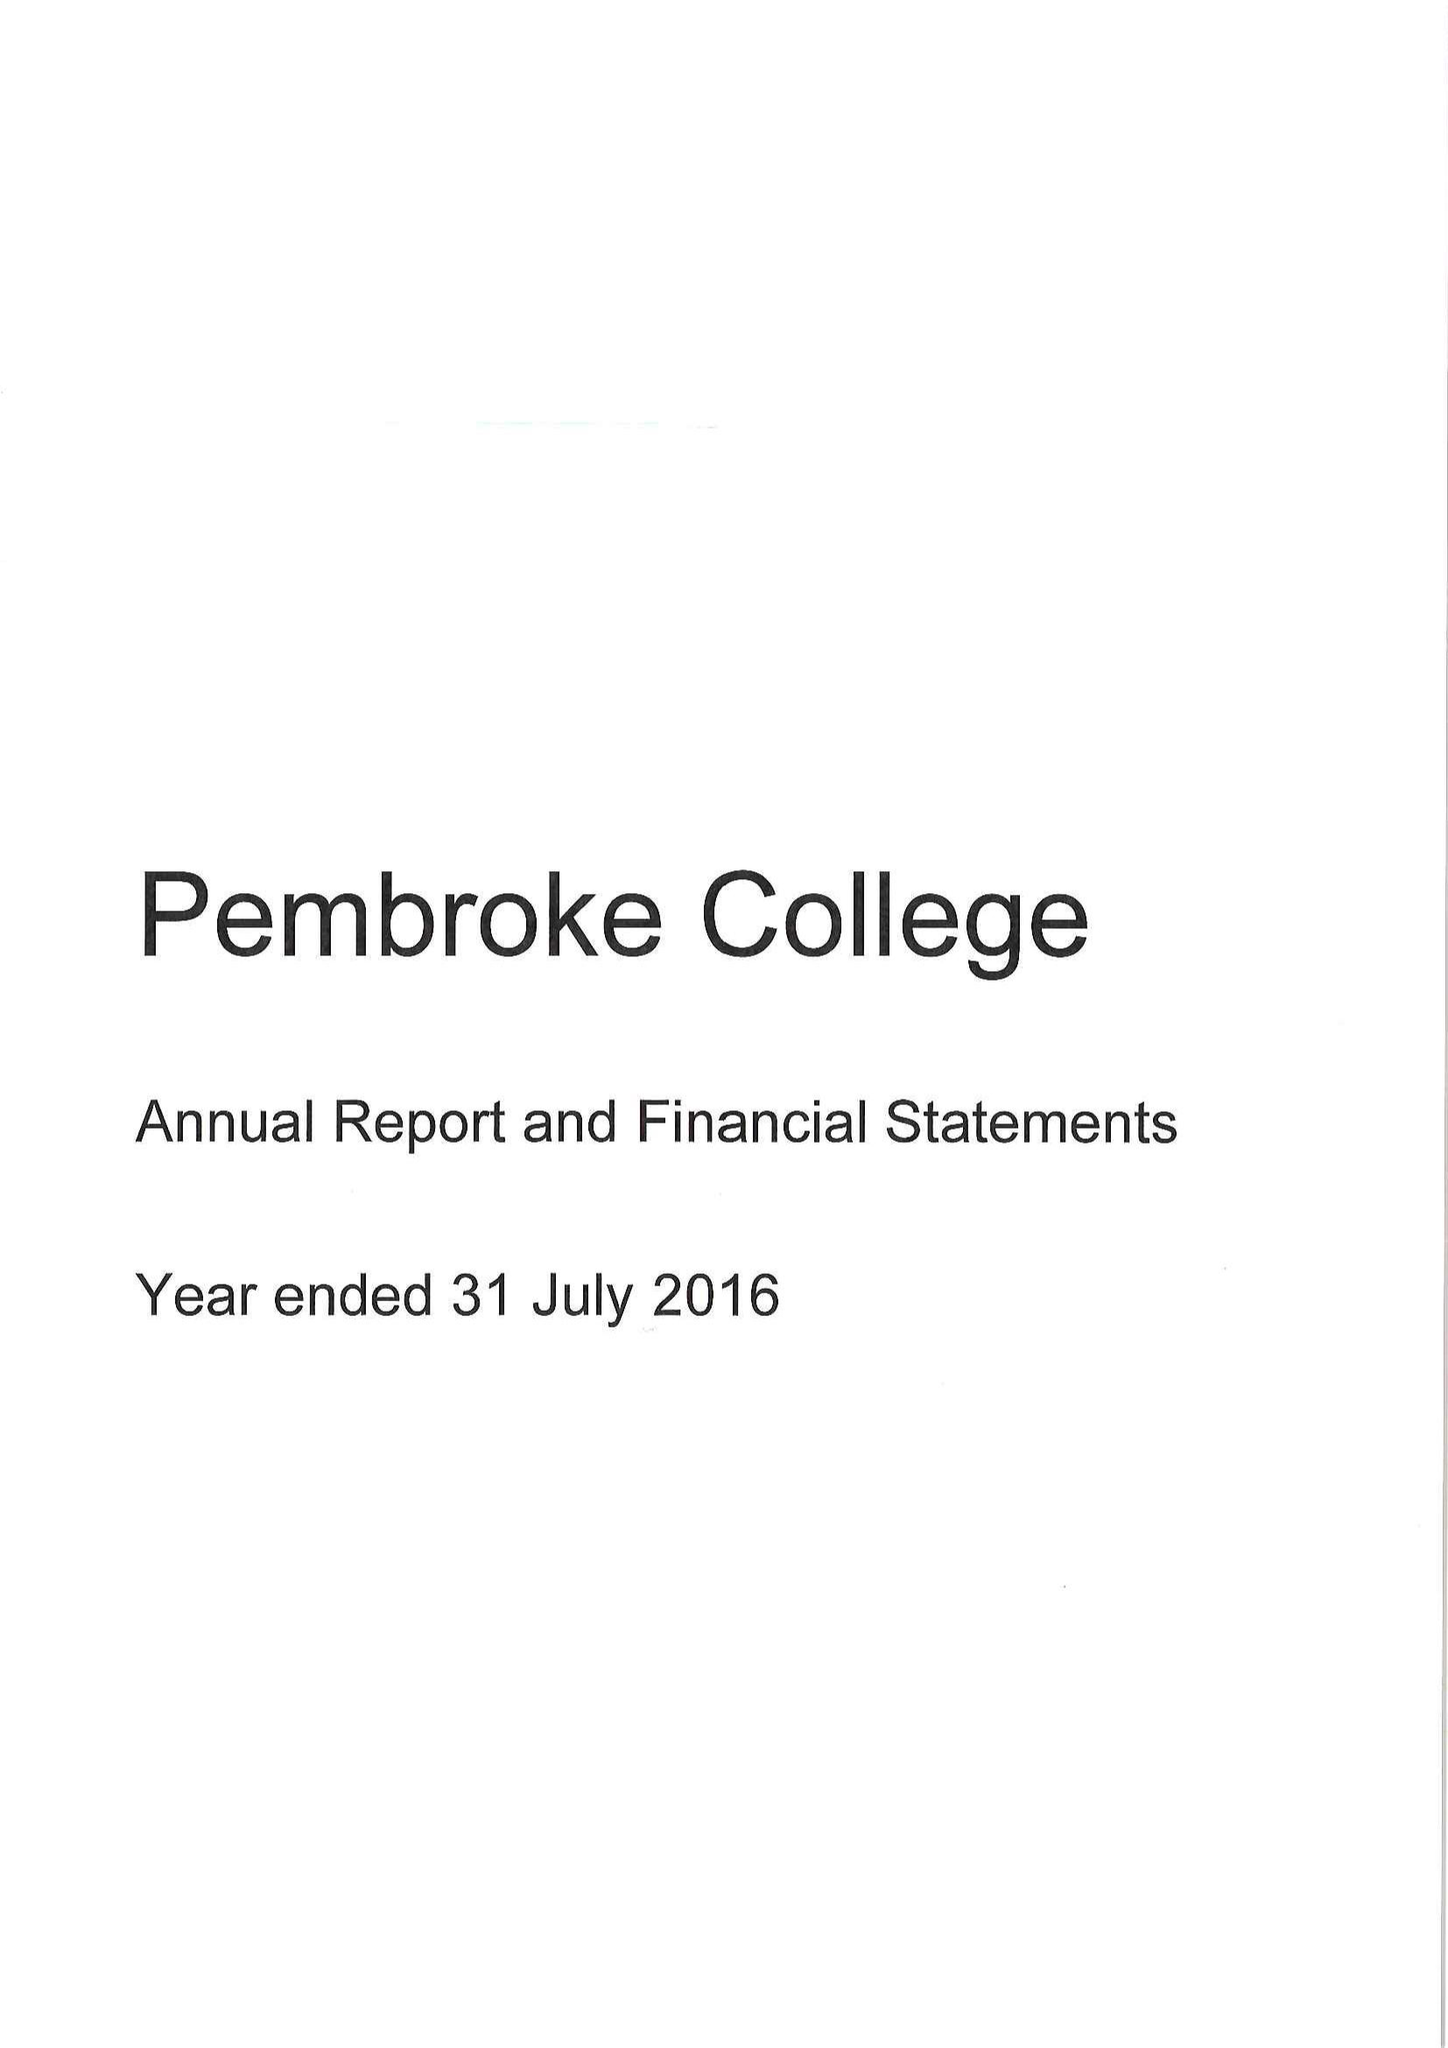What is the value for the address__postcode?
Answer the question using a single word or phrase. OX1 1DW 